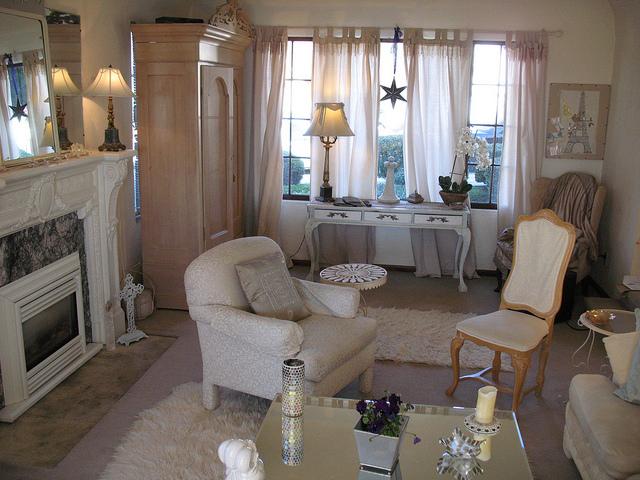How many stars are in the room?
Keep it brief. 1. Is the fireplace on?
Keep it brief. No. What is hanging in the window?
Answer briefly. Star. 